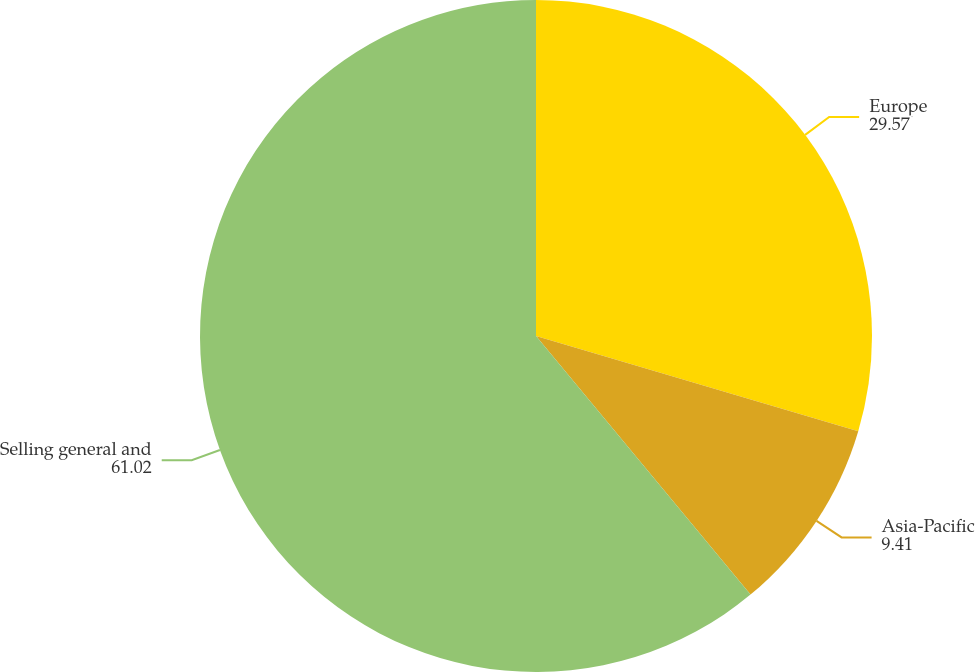Convert chart to OTSL. <chart><loc_0><loc_0><loc_500><loc_500><pie_chart><fcel>Europe<fcel>Asia-Pacific<fcel>Selling general and<nl><fcel>29.57%<fcel>9.41%<fcel>61.02%<nl></chart> 